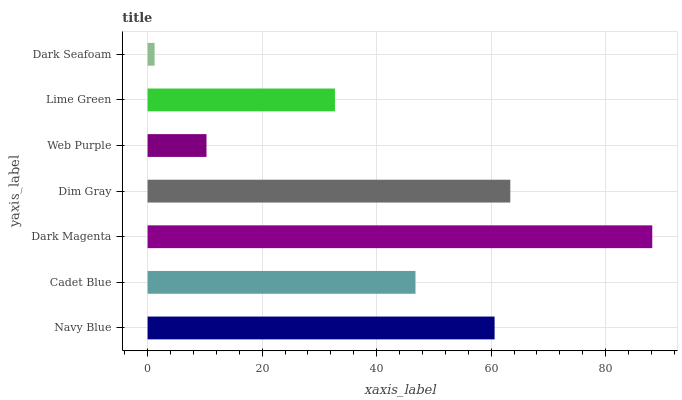Is Dark Seafoam the minimum?
Answer yes or no. Yes. Is Dark Magenta the maximum?
Answer yes or no. Yes. Is Cadet Blue the minimum?
Answer yes or no. No. Is Cadet Blue the maximum?
Answer yes or no. No. Is Navy Blue greater than Cadet Blue?
Answer yes or no. Yes. Is Cadet Blue less than Navy Blue?
Answer yes or no. Yes. Is Cadet Blue greater than Navy Blue?
Answer yes or no. No. Is Navy Blue less than Cadet Blue?
Answer yes or no. No. Is Cadet Blue the high median?
Answer yes or no. Yes. Is Cadet Blue the low median?
Answer yes or no. Yes. Is Navy Blue the high median?
Answer yes or no. No. Is Dark Magenta the low median?
Answer yes or no. No. 